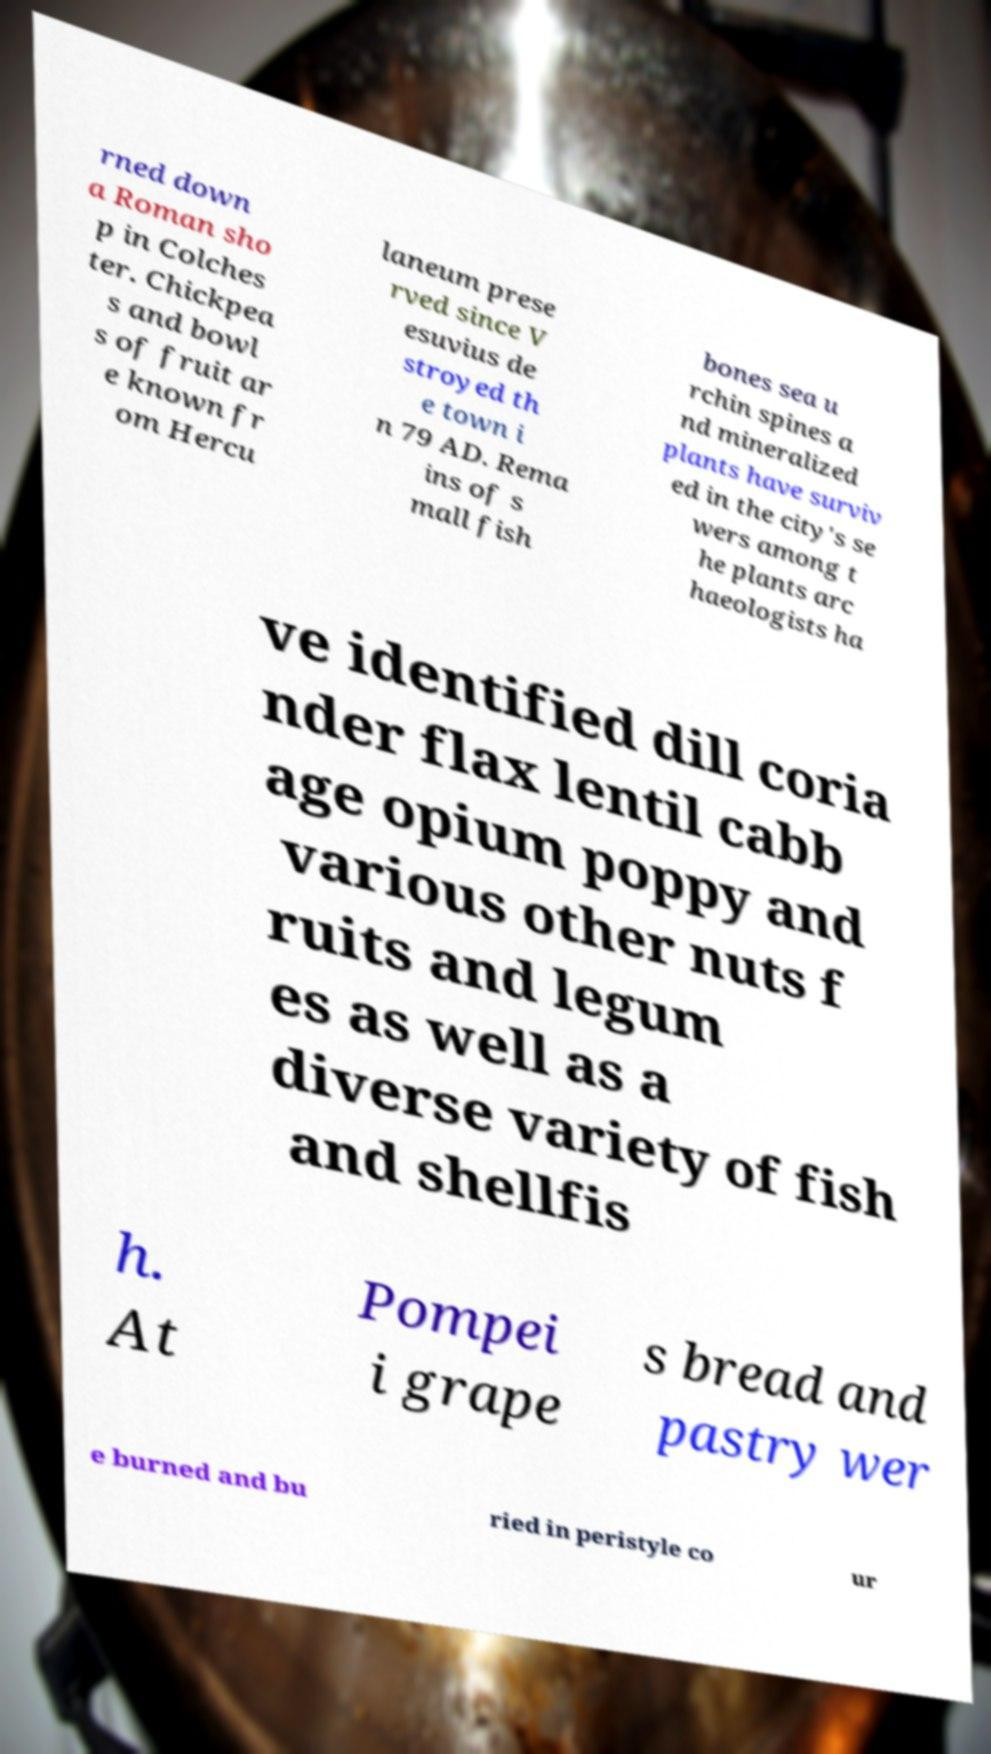For documentation purposes, I need the text within this image transcribed. Could you provide that? rned down a Roman sho p in Colches ter. Chickpea s and bowl s of fruit ar e known fr om Hercu laneum prese rved since V esuvius de stroyed th e town i n 79 AD. Rema ins of s mall fish bones sea u rchin spines a nd mineralized plants have surviv ed in the city's se wers among t he plants arc haeologists ha ve identified dill coria nder flax lentil cabb age opium poppy and various other nuts f ruits and legum es as well as a diverse variety of fish and shellfis h. At Pompei i grape s bread and pastry wer e burned and bu ried in peristyle co ur 